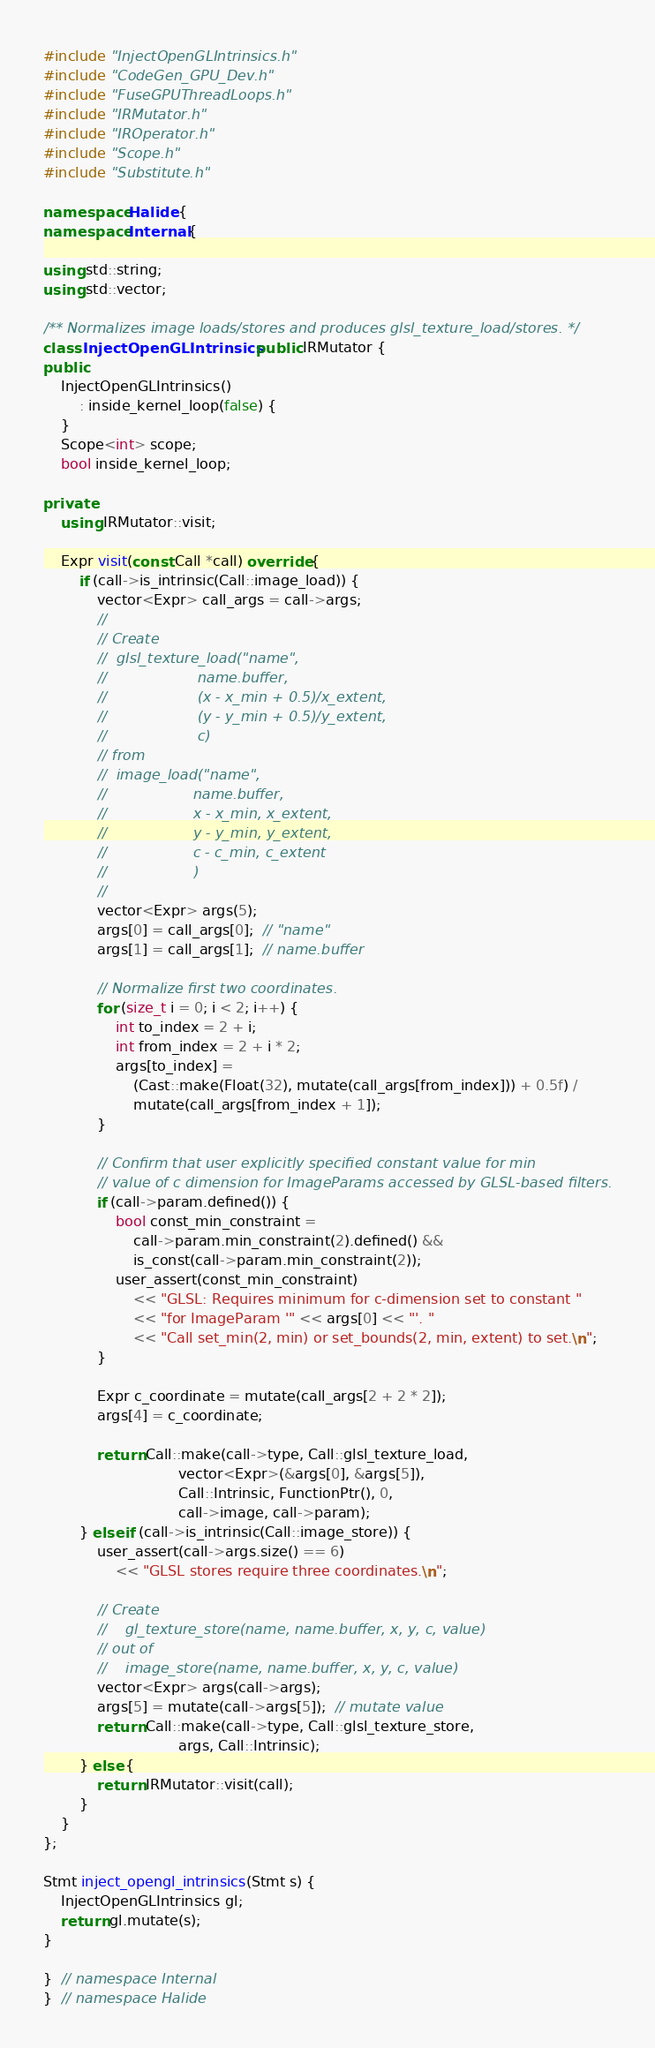Convert code to text. <code><loc_0><loc_0><loc_500><loc_500><_C++_>#include "InjectOpenGLIntrinsics.h"
#include "CodeGen_GPU_Dev.h"
#include "FuseGPUThreadLoops.h"
#include "IRMutator.h"
#include "IROperator.h"
#include "Scope.h"
#include "Substitute.h"

namespace Halide {
namespace Internal {

using std::string;
using std::vector;

/** Normalizes image loads/stores and produces glsl_texture_load/stores. */
class InjectOpenGLIntrinsics : public IRMutator {
public:
    InjectOpenGLIntrinsics()
        : inside_kernel_loop(false) {
    }
    Scope<int> scope;
    bool inside_kernel_loop;

private:
    using IRMutator::visit;

    Expr visit(const Call *call) override {
        if (call->is_intrinsic(Call::image_load)) {
            vector<Expr> call_args = call->args;
            //
            // Create
            //  glsl_texture_load("name",
            //                    name.buffer,
            //                    (x - x_min + 0.5)/x_extent,
            //                    (y - y_min + 0.5)/y_extent,
            //                    c)
            // from
            //  image_load("name",
            //                   name.buffer,
            //                   x - x_min, x_extent,
            //                   y - y_min, y_extent,
            //                   c - c_min, c_extent
            //                   )
            //
            vector<Expr> args(5);
            args[0] = call_args[0];  // "name"
            args[1] = call_args[1];  // name.buffer

            // Normalize first two coordinates.
            for (size_t i = 0; i < 2; i++) {
                int to_index = 2 + i;
                int from_index = 2 + i * 2;
                args[to_index] =
                    (Cast::make(Float(32), mutate(call_args[from_index])) + 0.5f) /
                    mutate(call_args[from_index + 1]);
            }

            // Confirm that user explicitly specified constant value for min
            // value of c dimension for ImageParams accessed by GLSL-based filters.
            if (call->param.defined()) {
                bool const_min_constraint =
                    call->param.min_constraint(2).defined() &&
                    is_const(call->param.min_constraint(2));
                user_assert(const_min_constraint)
                    << "GLSL: Requires minimum for c-dimension set to constant "
                    << "for ImageParam '" << args[0] << "'. "
                    << "Call set_min(2, min) or set_bounds(2, min, extent) to set.\n";
            }

            Expr c_coordinate = mutate(call_args[2 + 2 * 2]);
            args[4] = c_coordinate;

            return Call::make(call->type, Call::glsl_texture_load,
                              vector<Expr>(&args[0], &args[5]),
                              Call::Intrinsic, FunctionPtr(), 0,
                              call->image, call->param);
        } else if (call->is_intrinsic(Call::image_store)) {
            user_assert(call->args.size() == 6)
                << "GLSL stores require three coordinates.\n";

            // Create
            //    gl_texture_store(name, name.buffer, x, y, c, value)
            // out of
            //    image_store(name, name.buffer, x, y, c, value)
            vector<Expr> args(call->args);
            args[5] = mutate(call->args[5]);  // mutate value
            return Call::make(call->type, Call::glsl_texture_store,
                              args, Call::Intrinsic);
        } else {
            return IRMutator::visit(call);
        }
    }
};

Stmt inject_opengl_intrinsics(Stmt s) {
    InjectOpenGLIntrinsics gl;
    return gl.mutate(s);
}

}  // namespace Internal
}  // namespace Halide
</code> 